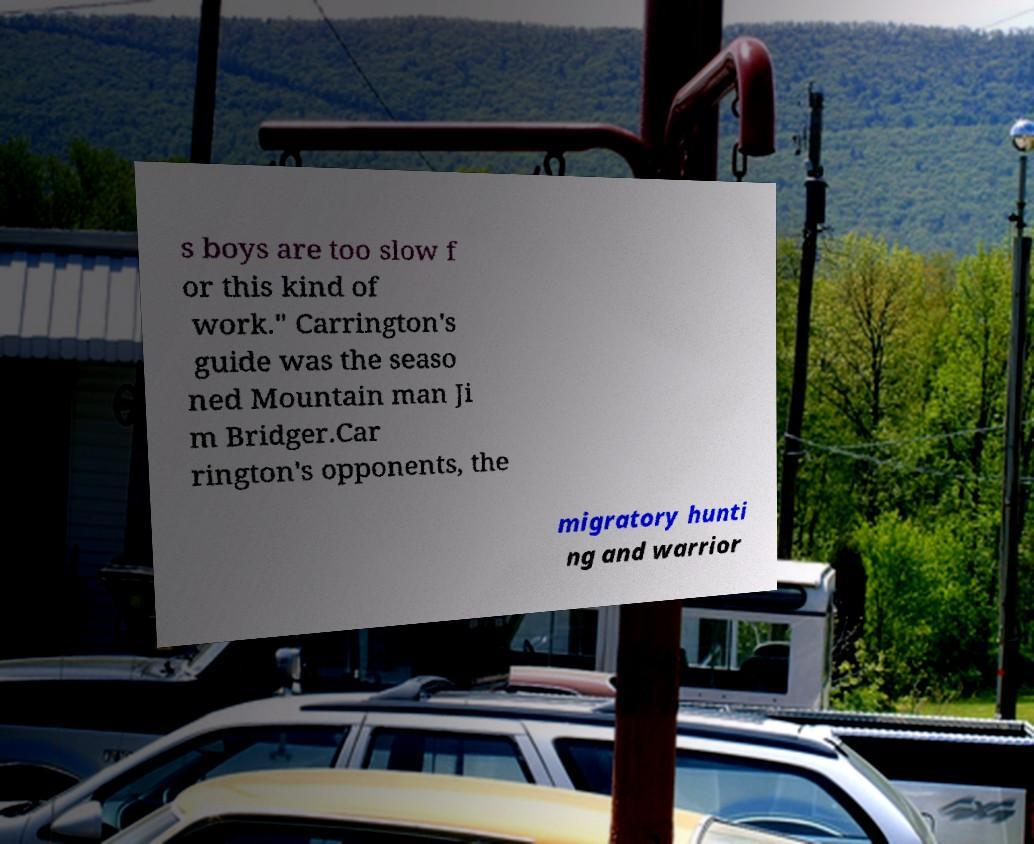Can you accurately transcribe the text from the provided image for me? s boys are too slow f or this kind of work." Carrington's guide was the seaso ned Mountain man Ji m Bridger.Car rington's opponents, the migratory hunti ng and warrior 